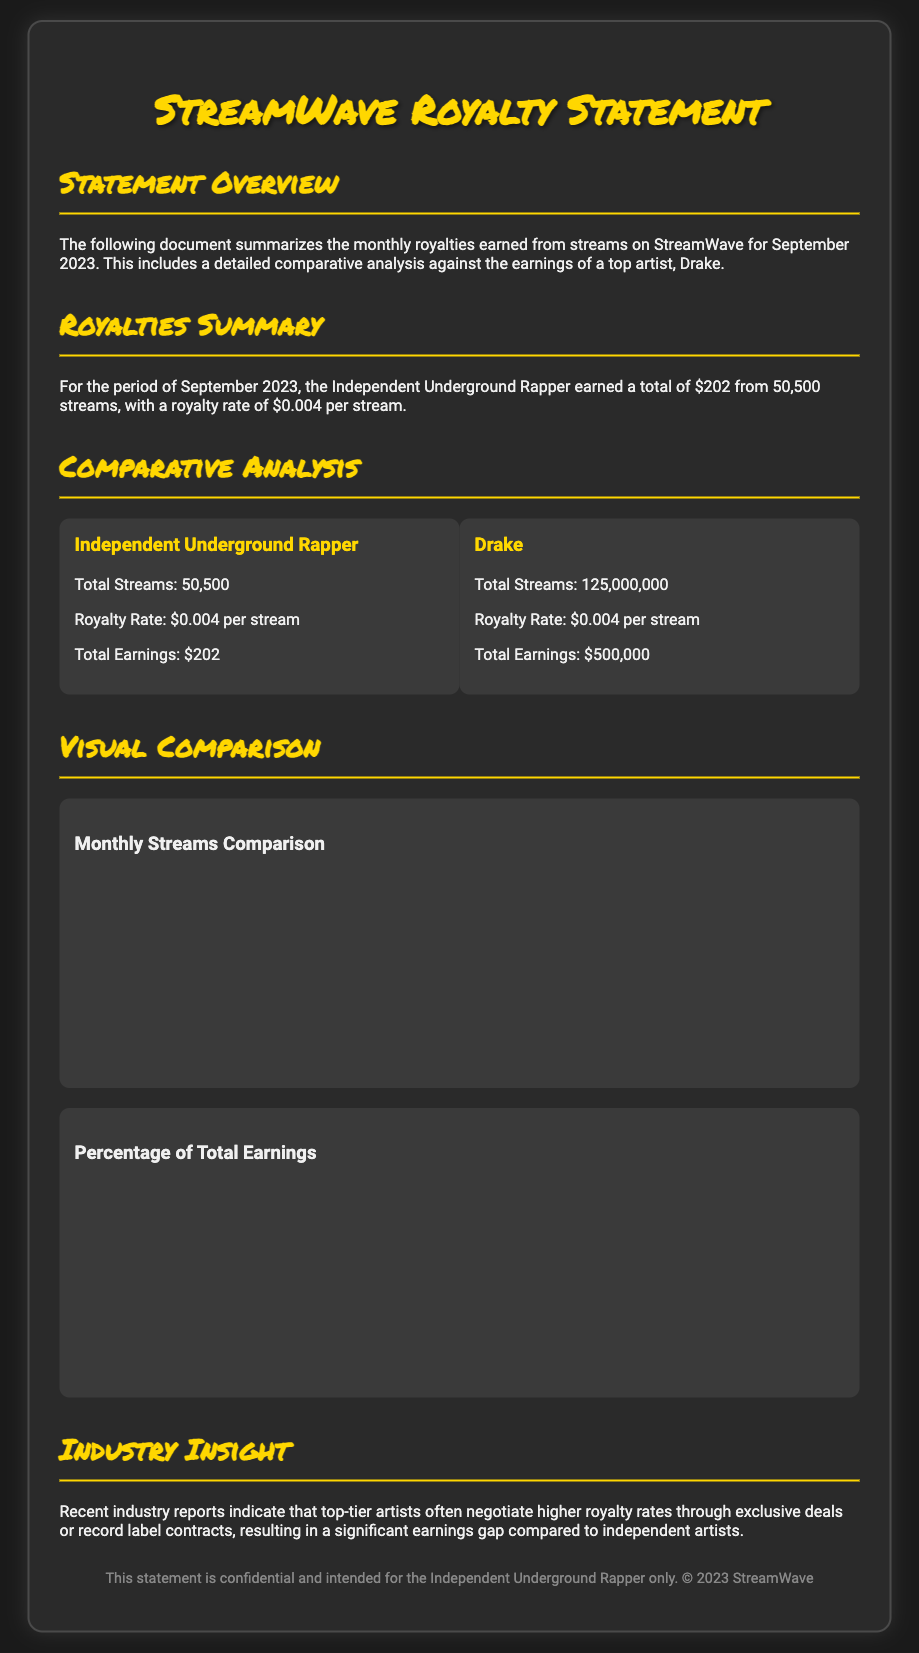What is the total amount earned by the Independent Underground Rapper? The document states that the Independent Underground Rapper earned a total of $202 from streams.
Answer: $202 How many streams did the Independent Underground Rapper receive? According to the document, the Independent Underground Rapper had 50,500 streams.
Answer: 50,500 What is Drake's total earnings for the month? The document indicates that Drake earned a total of $500,000 from his streams.
Answer: $500,000 What is the royalty rate per stream for both artists? The document states that both the Independent Underground Rapper and Drake have a royalty rate of $0.004 per stream.
Answer: $0.004 What is the percentage of total earnings for the Independent Underground Rapper compared to Drake? The document describes that the Independent Underground Rapper accounts for 0.04% of the total earnings against Drake’s 99.96%.
Answer: 0.04% How many total streams did Drake receive? The document mentions that Drake had a total of 125,000,000 streams.
Answer: 125,000,000 What does the industry report suggest about earnings gaps? The document states that top-tier artists often negotiate higher royalty rates, leading to significant earnings gaps compared to independent artists.
Answer: Higher royalty rates What type of analysis is provided in the document? The document contains a comparative analysis between the Independent Underground Rapper and Drake's earnings from streams.
Answer: Comparative analysis What is the title of the document? The document is titled "StreamWave Royalty Statement."
Answer: StreamWave Royalty Statement 